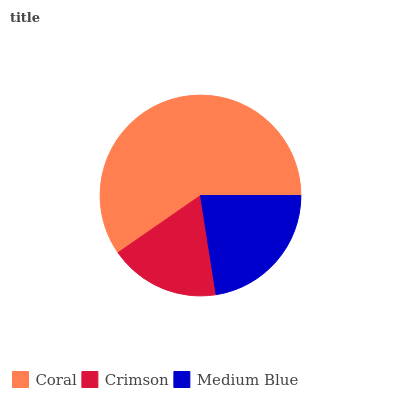Is Crimson the minimum?
Answer yes or no. Yes. Is Coral the maximum?
Answer yes or no. Yes. Is Medium Blue the minimum?
Answer yes or no. No. Is Medium Blue the maximum?
Answer yes or no. No. Is Medium Blue greater than Crimson?
Answer yes or no. Yes. Is Crimson less than Medium Blue?
Answer yes or no. Yes. Is Crimson greater than Medium Blue?
Answer yes or no. No. Is Medium Blue less than Crimson?
Answer yes or no. No. Is Medium Blue the high median?
Answer yes or no. Yes. Is Medium Blue the low median?
Answer yes or no. Yes. Is Crimson the high median?
Answer yes or no. No. Is Crimson the low median?
Answer yes or no. No. 